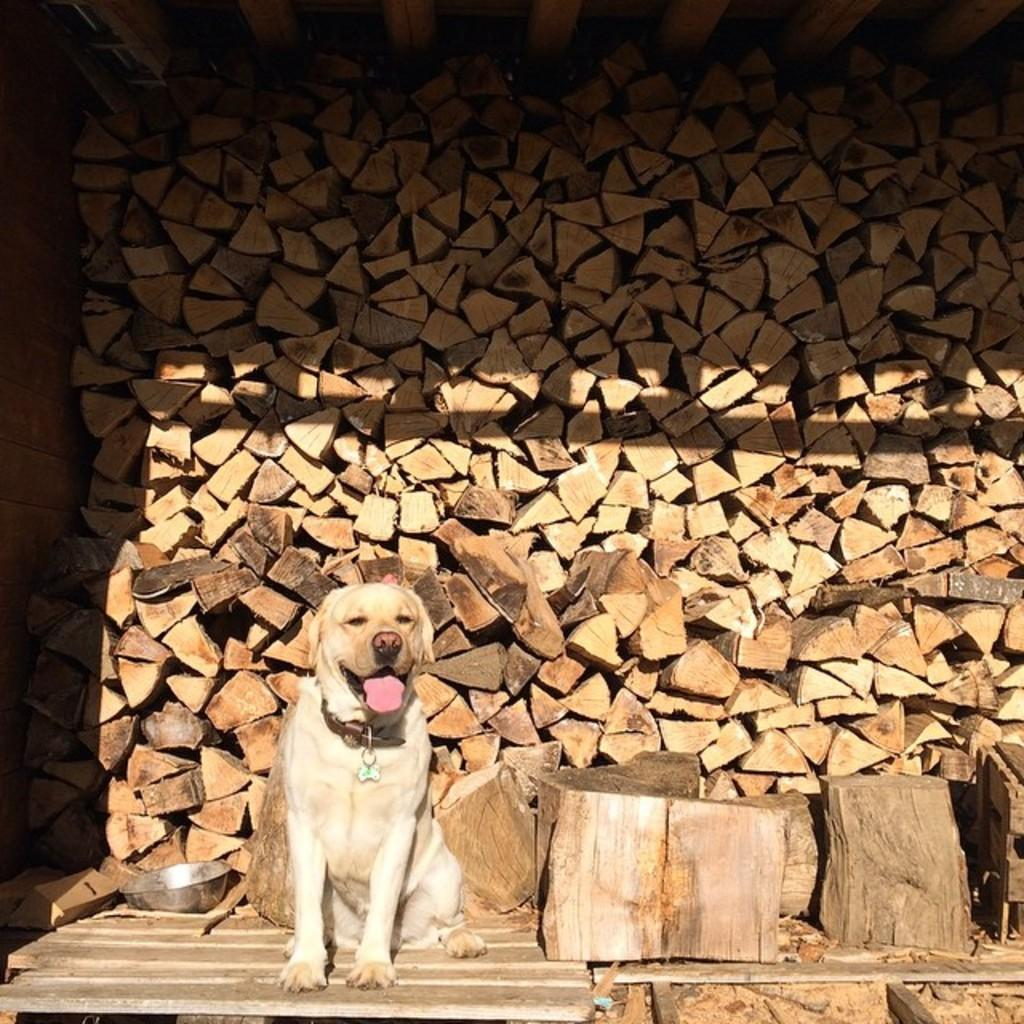What animal is sitting in the image? There is a dog sitting in the image. What type of material is on the right side of the image? There is wood on the right side of the image. What can be seen in the background of the image? There is lumber wood visible in the background of the image. What type of container is on the left side of the image? There is a steel bowl on the left side of the image. How does the dog use the scale in the image? There is no scale present in the image, so the dog cannot use it. 